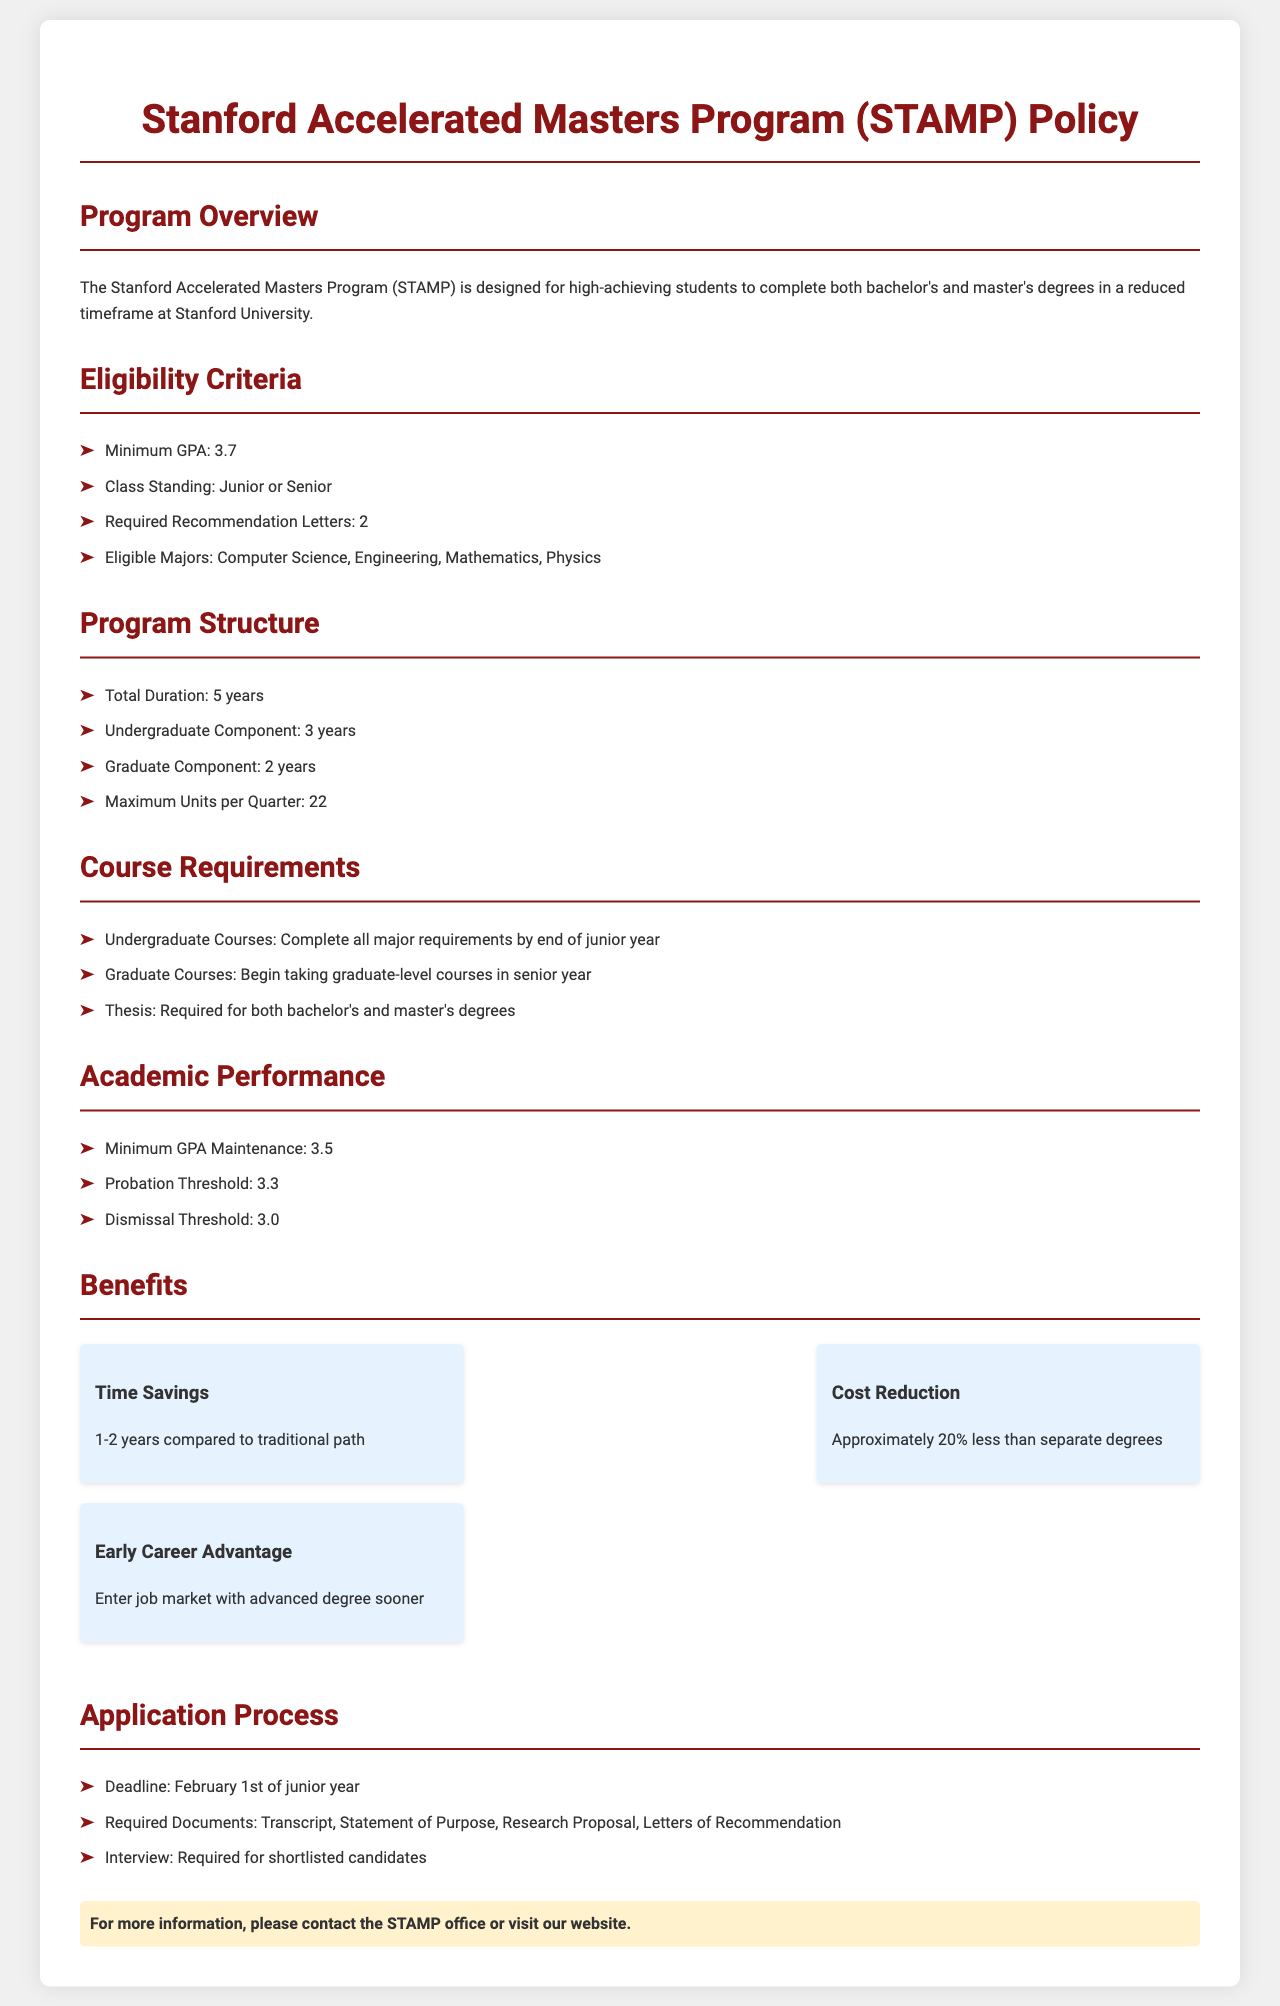What is the minimum GPA required for eligibility? The minimum GPA for eligibility is specified in the document under eligibility criteria.
Answer: 3.7 What is the total duration of the program? The total duration of the program is stated in the program structure section.
Answer: 5 years How many recommendation letters are required? The document explicitly mentions the number of recommendation letters required for eligibility.
Answer: 2 What is the probation threshold GPA? The probation threshold GPA is detailed in the academic performance section.
Answer: 3.3 Which majors are eligible for the program? The document lists eligible majors under the eligibility criteria section.
Answer: Computer Science, Engineering, Mathematics, Physics What is the maximum number of units allowed per quarter? The maximum units per quarter can be found in the program structure section.
Answer: 22 What is the application deadline? The application deadline is outlined in the application process section of the document.
Answer: February 1st When can students begin taking graduate-level courses? The document specifies when students can start taking graduate-level courses in the course requirements section.
Answer: Senior year What is the cost reduction percentage compared to separate degrees? The benefits section highlights the cost reduction percentage for the program.
Answer: Approximately 20% 